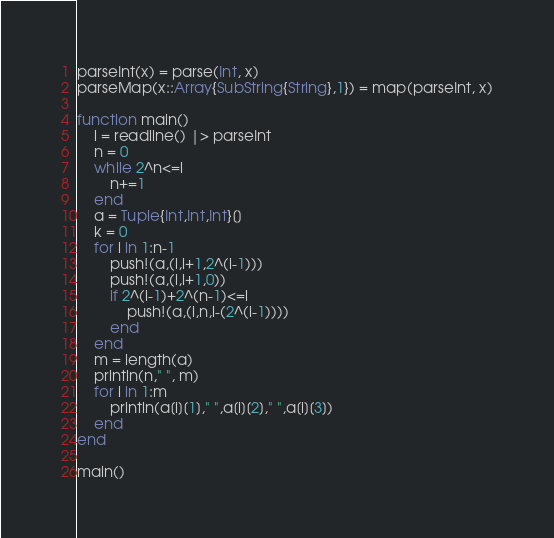Convert code to text. <code><loc_0><loc_0><loc_500><loc_500><_Julia_>parseInt(x) = parse(Int, x)
parseMap(x::Array{SubString{String},1}) = map(parseInt, x)

function main()
	l = readline() |> parseInt
	n = 0
	while 2^n<=l
		n+=1
	end
	a = Tuple{Int,Int,Int}[]
	k = 0
	for i in 1:n-1
		push!(a,(i,i+1,2^(i-1)))
		push!(a,(i,i+1,0))
		if 2^(i-1)+2^(n-1)<=l
			push!(a,(i,n,l-(2^(i-1))))
		end
	end
	m = length(a)
	println(n," ", m)
	for i in 1:m
		println(a[i][1]," ",a[i][2]," ",a[i][3])
	end
end

main()</code> 